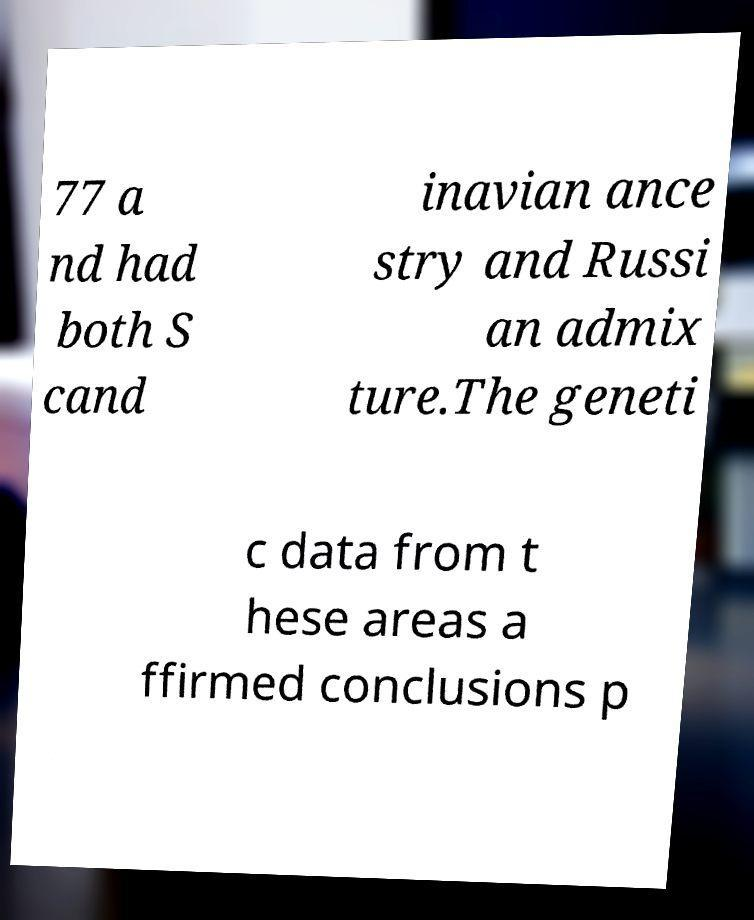Can you read and provide the text displayed in the image?This photo seems to have some interesting text. Can you extract and type it out for me? 77 a nd had both S cand inavian ance stry and Russi an admix ture.The geneti c data from t hese areas a ffirmed conclusions p 